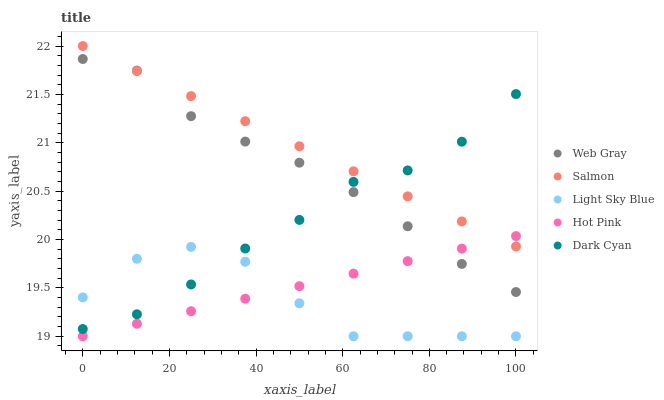Does Light Sky Blue have the minimum area under the curve?
Answer yes or no. Yes. Does Salmon have the maximum area under the curve?
Answer yes or no. Yes. Does Web Gray have the minimum area under the curve?
Answer yes or no. No. Does Web Gray have the maximum area under the curve?
Answer yes or no. No. Is Salmon the smoothest?
Answer yes or no. Yes. Is Light Sky Blue the roughest?
Answer yes or no. Yes. Is Web Gray the smoothest?
Answer yes or no. No. Is Web Gray the roughest?
Answer yes or no. No. Does Light Sky Blue have the lowest value?
Answer yes or no. Yes. Does Web Gray have the lowest value?
Answer yes or no. No. Does Salmon have the highest value?
Answer yes or no. Yes. Does Web Gray have the highest value?
Answer yes or no. No. Is Light Sky Blue less than Web Gray?
Answer yes or no. Yes. Is Dark Cyan greater than Hot Pink?
Answer yes or no. Yes. Does Salmon intersect Dark Cyan?
Answer yes or no. Yes. Is Salmon less than Dark Cyan?
Answer yes or no. No. Is Salmon greater than Dark Cyan?
Answer yes or no. No. Does Light Sky Blue intersect Web Gray?
Answer yes or no. No. 